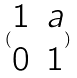Convert formula to latex. <formula><loc_0><loc_0><loc_500><loc_500>( \begin{matrix} 1 & a \\ 0 & 1 \end{matrix} )</formula> 